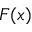Convert formula to latex. <formula><loc_0><loc_0><loc_500><loc_500>F ( x )</formula> 